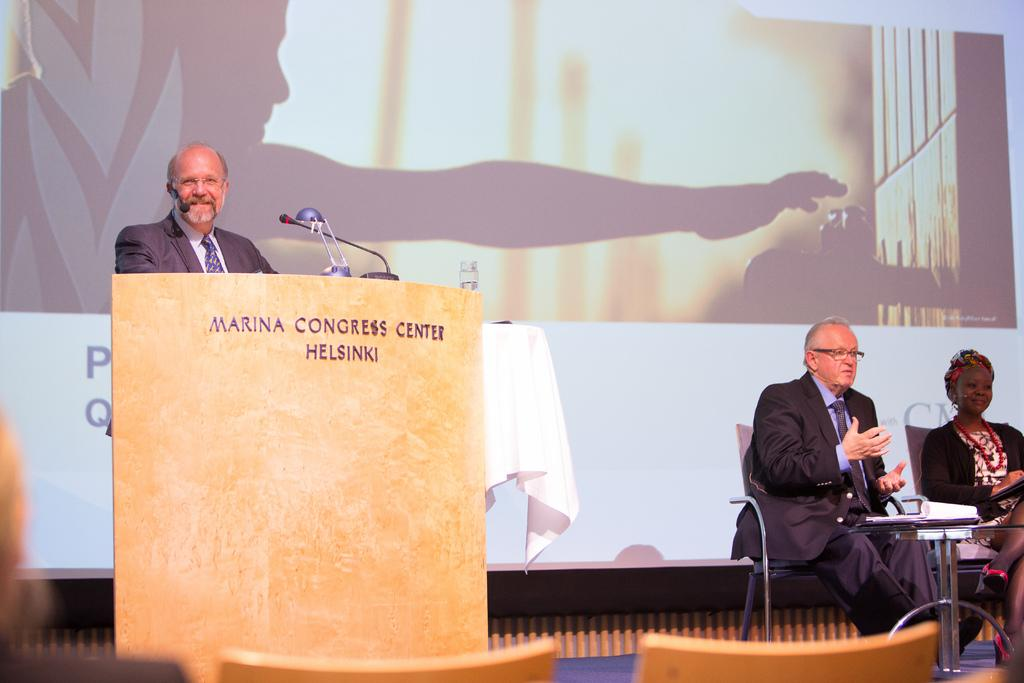Who is the main subject in the image? There is a man in the image. What is the man standing in front of? There is a podium with a mic in front of the man. What can be seen in the background of the image? There is a screen in the background of the image. How many people are sitting in the image? Two people are sitting on chairs. What is present between the two people? There is a table in front of the two people. What type of plastic is used to make the cherries on the table? There are no cherries present on the table in the image. 